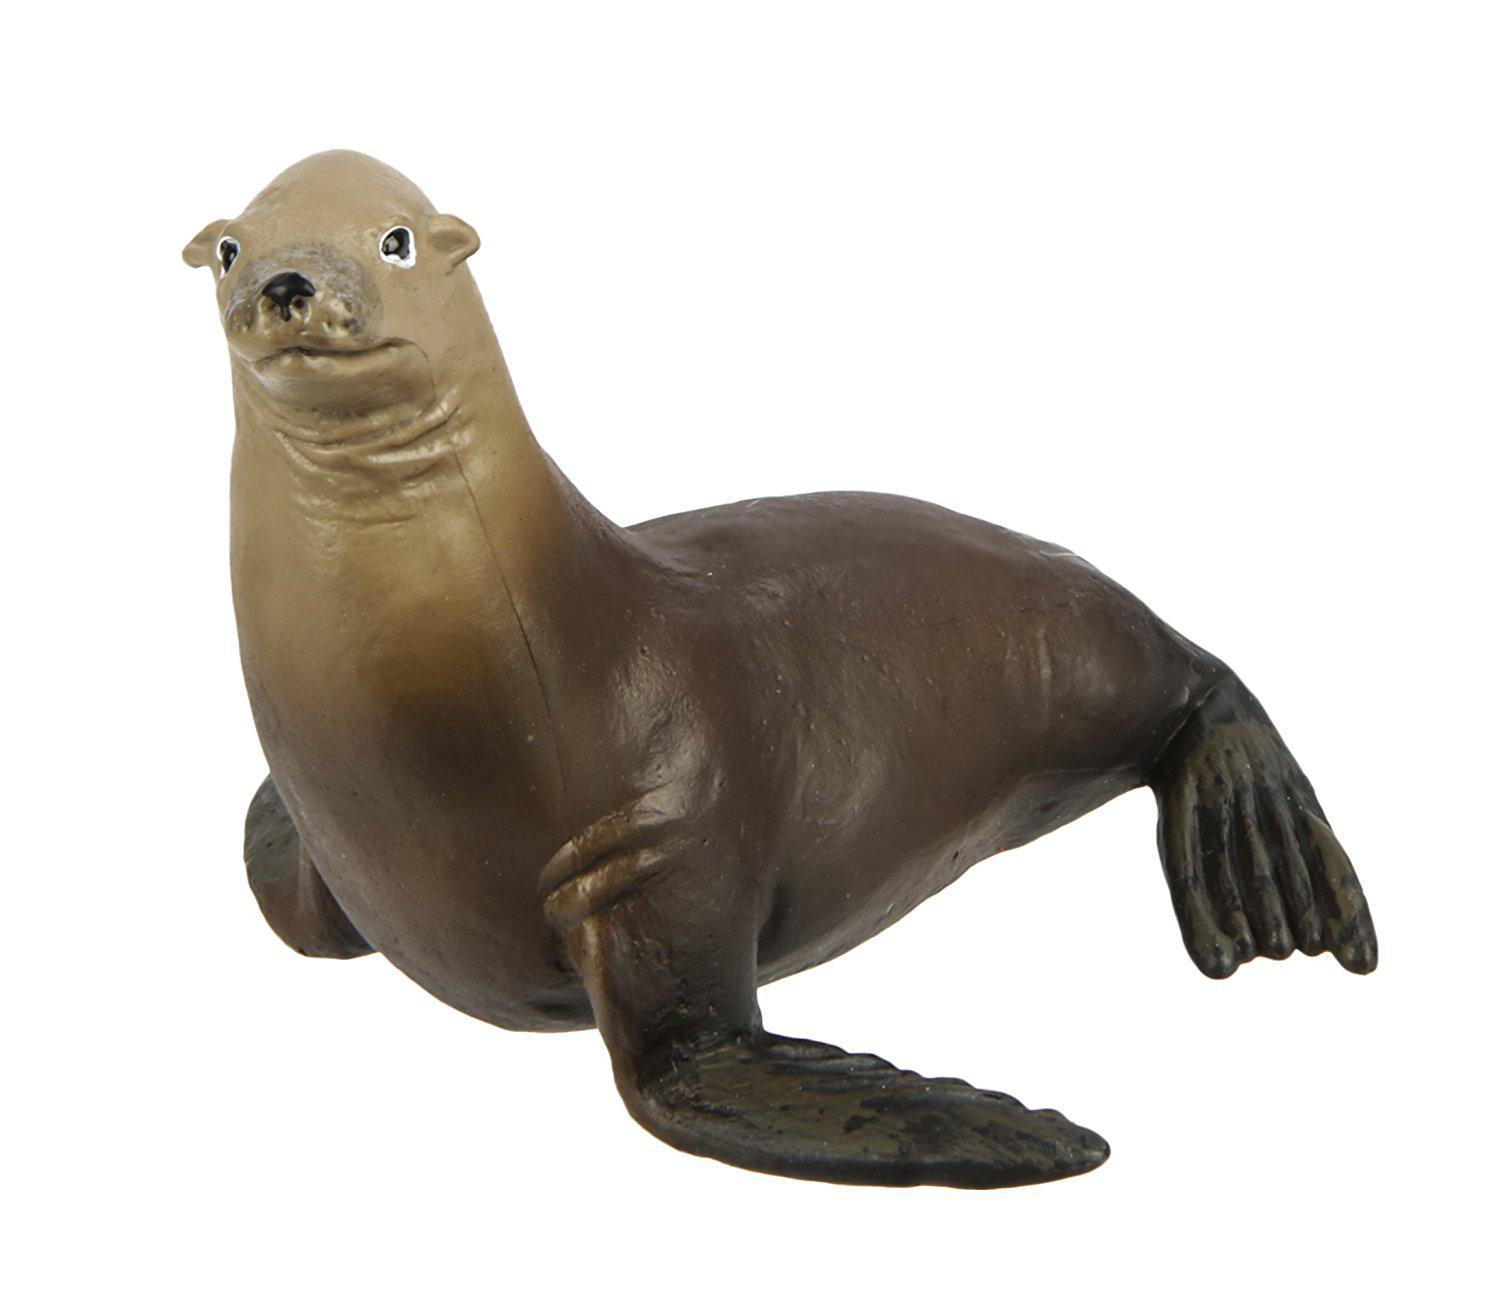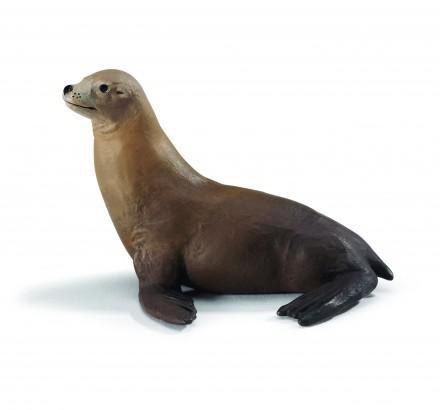The first image is the image on the left, the second image is the image on the right. Evaluate the accuracy of this statement regarding the images: "1 seal is pointed toward the right outside.". Is it true? Answer yes or no. No. 